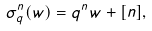<formula> <loc_0><loc_0><loc_500><loc_500>\sigma ^ { n } _ { q } ( w ) = q ^ { n } w + [ n ] ,</formula> 